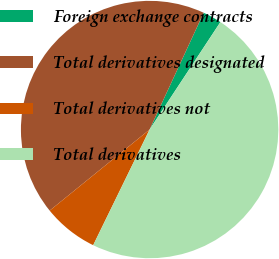Convert chart. <chart><loc_0><loc_0><loc_500><loc_500><pie_chart><fcel>Foreign exchange contracts<fcel>Total derivatives designated<fcel>Total derivatives not<fcel>Total derivatives<nl><fcel>2.37%<fcel>42.75%<fcel>6.93%<fcel>47.96%<nl></chart> 